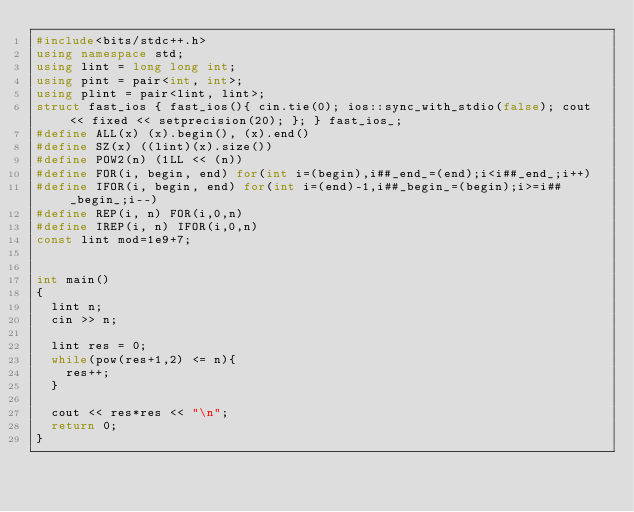Convert code to text. <code><loc_0><loc_0><loc_500><loc_500><_C++_>#include<bits/stdc++.h>
using namespace std;
using lint = long long int;
using pint = pair<int, int>;
using plint = pair<lint, lint>;
struct fast_ios { fast_ios(){ cin.tie(0); ios::sync_with_stdio(false); cout << fixed << setprecision(20); }; } fast_ios_;
#define ALL(x) (x).begin(), (x).end()
#define SZ(x) ((lint)(x).size())
#define POW2(n) (1LL << (n))
#define FOR(i, begin, end) for(int i=(begin),i##_end_=(end);i<i##_end_;i++)
#define IFOR(i, begin, end) for(int i=(end)-1,i##_begin_=(begin);i>=i##_begin_;i--)
#define REP(i, n) FOR(i,0,n)
#define IREP(i, n) IFOR(i,0,n)
const lint mod=1e9+7;


int main()
{
  lint n;
  cin >> n;

  lint res = 0;
  while(pow(res+1,2) <= n){
    res++;
  }

  cout << res*res << "\n";
  return 0;
}
</code> 